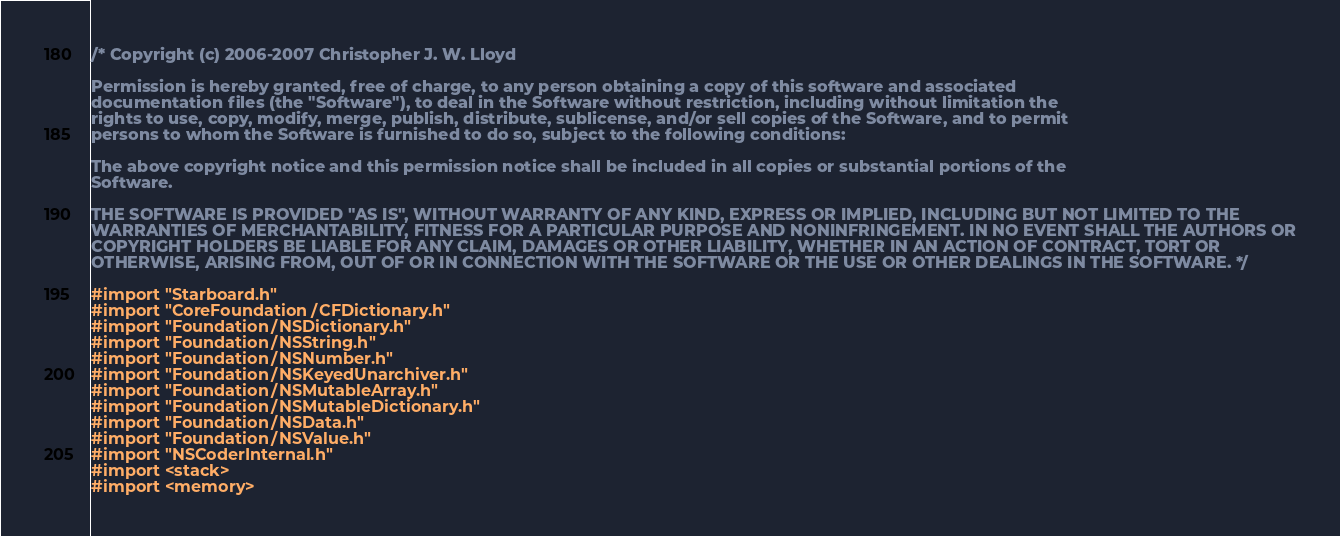Convert code to text. <code><loc_0><loc_0><loc_500><loc_500><_ObjectiveC_>/* Copyright (c) 2006-2007 Christopher J. W. Lloyd

Permission is hereby granted, free of charge, to any person obtaining a copy of this software and associated
documentation files (the "Software"), to deal in the Software without restriction, including without limitation the
rights to use, copy, modify, merge, publish, distribute, sublicense, and/or sell copies of the Software, and to permit
persons to whom the Software is furnished to do so, subject to the following conditions:

The above copyright notice and this permission notice shall be included in all copies or substantial portions of the
Software.

THE SOFTWARE IS PROVIDED "AS IS", WITHOUT WARRANTY OF ANY KIND, EXPRESS OR IMPLIED, INCLUDING BUT NOT LIMITED TO THE
WARRANTIES OF MERCHANTABILITY, FITNESS FOR A PARTICULAR PURPOSE AND NONINFRINGEMENT. IN NO EVENT SHALL THE AUTHORS OR
COPYRIGHT HOLDERS BE LIABLE FOR ANY CLAIM, DAMAGES OR OTHER LIABILITY, WHETHER IN AN ACTION OF CONTRACT, TORT OR
OTHERWISE, ARISING FROM, OUT OF OR IN CONNECTION WITH THE SOFTWARE OR THE USE OR OTHER DEALINGS IN THE SOFTWARE. */

#import "Starboard.h"
#import "CoreFoundation/CFDictionary.h"
#import "Foundation/NSDictionary.h"
#import "Foundation/NSString.h"
#import "Foundation/NSNumber.h"
#import "Foundation/NSKeyedUnarchiver.h"
#import "Foundation/NSMutableArray.h"
#import "Foundation/NSMutableDictionary.h"
#import "Foundation/NSData.h"
#import "Foundation/NSValue.h"
#import "NSCoderInternal.h"
#import <stack>
#import <memory></code> 